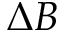<formula> <loc_0><loc_0><loc_500><loc_500>\Delta B</formula> 